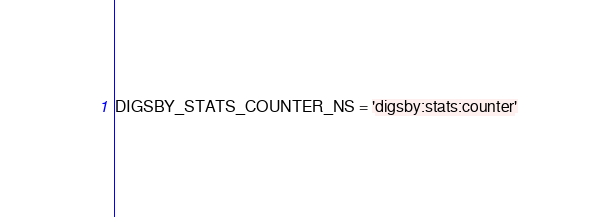<code> <loc_0><loc_0><loc_500><loc_500><_Python_>DIGSBY_STATS_COUNTER_NS = 'digsby:stats:counter'</code> 